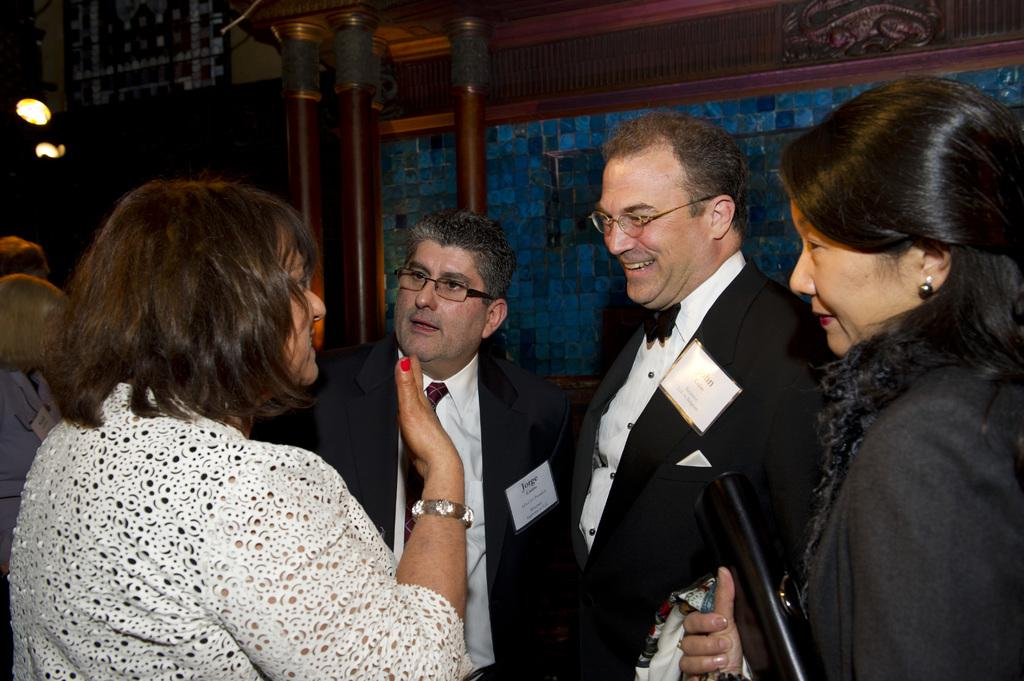How many men are in the image? There are two men in the image. What are the men wearing? The men are wearing blazers. How many women are in the image? There are two women in the image. What can be seen in the background of the image? In the background, there are more people, a wall, pillars, and lights. What type of chair is the queen sitting on in the image? There is no queen or chair present in the image. 